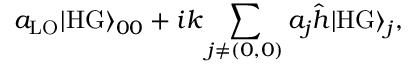Convert formula to latex. <formula><loc_0><loc_0><loc_500><loc_500>a _ { L O } | H G \rangle _ { 0 0 } + i k \sum _ { j \neq ( 0 , 0 ) } a _ { j } \hat { h } | H G \rangle _ { j } ,</formula> 